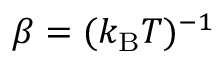Convert formula to latex. <formula><loc_0><loc_0><loc_500><loc_500>\beta = ( k _ { B } T ) ^ { - 1 }</formula> 